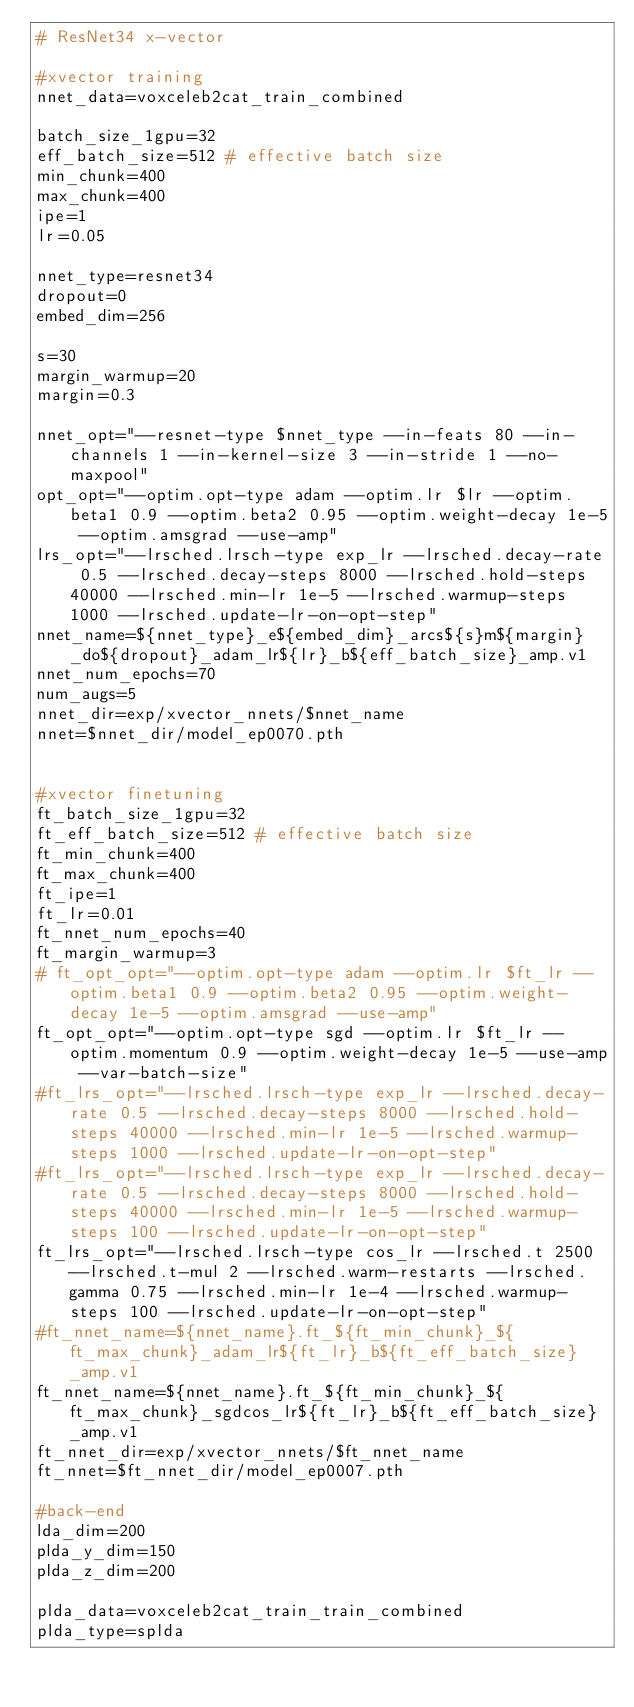Convert code to text. <code><loc_0><loc_0><loc_500><loc_500><_Bash_># ResNet34 x-vector

#xvector training 
nnet_data=voxceleb2cat_train_combined

batch_size_1gpu=32
eff_batch_size=512 # effective batch size
min_chunk=400
max_chunk=400
ipe=1
lr=0.05

nnet_type=resnet34
dropout=0
embed_dim=256

s=30
margin_warmup=20
margin=0.3

nnet_opt="--resnet-type $nnet_type --in-feats 80 --in-channels 1 --in-kernel-size 3 --in-stride 1 --no-maxpool"
opt_opt="--optim.opt-type adam --optim.lr $lr --optim.beta1 0.9 --optim.beta2 0.95 --optim.weight-decay 1e-5 --optim.amsgrad --use-amp"
lrs_opt="--lrsched.lrsch-type exp_lr --lrsched.decay-rate 0.5 --lrsched.decay-steps 8000 --lrsched.hold-steps 40000 --lrsched.min-lr 1e-5 --lrsched.warmup-steps 1000 --lrsched.update-lr-on-opt-step"
nnet_name=${nnet_type}_e${embed_dim}_arcs${s}m${margin}_do${dropout}_adam_lr${lr}_b${eff_batch_size}_amp.v1
nnet_num_epochs=70
num_augs=5
nnet_dir=exp/xvector_nnets/$nnet_name
nnet=$nnet_dir/model_ep0070.pth


#xvector finetuning
ft_batch_size_1gpu=32
ft_eff_batch_size=512 # effective batch size
ft_min_chunk=400
ft_max_chunk=400
ft_ipe=1
ft_lr=0.01
ft_nnet_num_epochs=40
ft_margin_warmup=3
# ft_opt_opt="--optim.opt-type adam --optim.lr $ft_lr --optim.beta1 0.9 --optim.beta2 0.95 --optim.weight-decay 1e-5 --optim.amsgrad --use-amp"
ft_opt_opt="--optim.opt-type sgd --optim.lr $ft_lr --optim.momentum 0.9 --optim.weight-decay 1e-5 --use-amp --var-batch-size"
#ft_lrs_opt="--lrsched.lrsch-type exp_lr --lrsched.decay-rate 0.5 --lrsched.decay-steps 8000 --lrsched.hold-steps 40000 --lrsched.min-lr 1e-5 --lrsched.warmup-steps 1000 --lrsched.update-lr-on-opt-step"
#ft_lrs_opt="--lrsched.lrsch-type exp_lr --lrsched.decay-rate 0.5 --lrsched.decay-steps 8000 --lrsched.hold-steps 40000 --lrsched.min-lr 1e-5 --lrsched.warmup-steps 100 --lrsched.update-lr-on-opt-step"
ft_lrs_opt="--lrsched.lrsch-type cos_lr --lrsched.t 2500 --lrsched.t-mul 2 --lrsched.warm-restarts --lrsched.gamma 0.75 --lrsched.min-lr 1e-4 --lrsched.warmup-steps 100 --lrsched.update-lr-on-opt-step"
#ft_nnet_name=${nnet_name}.ft_${ft_min_chunk}_${ft_max_chunk}_adam_lr${ft_lr}_b${ft_eff_batch_size}_amp.v1
ft_nnet_name=${nnet_name}.ft_${ft_min_chunk}_${ft_max_chunk}_sgdcos_lr${ft_lr}_b${ft_eff_batch_size}_amp.v1
ft_nnet_dir=exp/xvector_nnets/$ft_nnet_name
ft_nnet=$ft_nnet_dir/model_ep0007.pth

#back-end
lda_dim=200
plda_y_dim=150
plda_z_dim=200

plda_data=voxceleb2cat_train_train_combined
plda_type=splda
</code> 